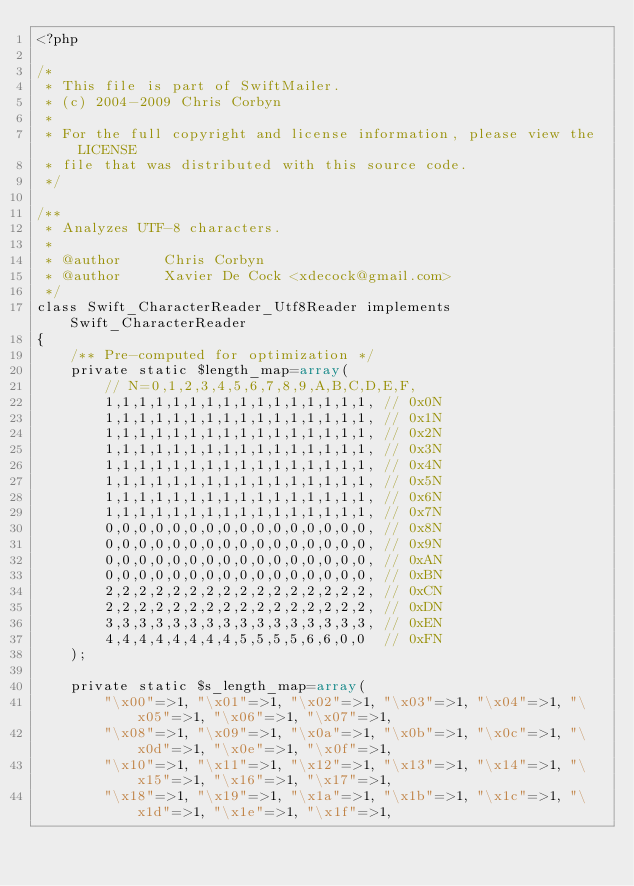Convert code to text. <code><loc_0><loc_0><loc_500><loc_500><_PHP_><?php

/*
 * This file is part of SwiftMailer.
 * (c) 2004-2009 Chris Corbyn
 *
 * For the full copyright and license information, please view the LICENSE
 * file that was distributed with this source code.
 */

/**
 * Analyzes UTF-8 characters.
 *
 * @author     Chris Corbyn
 * @author     Xavier De Cock <xdecock@gmail.com>
 */
class Swift_CharacterReader_Utf8Reader implements Swift_CharacterReader
{
    /** Pre-computed for optimization */
    private static $length_map=array(
        // N=0,1,2,3,4,5,6,7,8,9,A,B,C,D,E,F,
        1,1,1,1,1,1,1,1,1,1,1,1,1,1,1,1, // 0x0N
        1,1,1,1,1,1,1,1,1,1,1,1,1,1,1,1, // 0x1N
        1,1,1,1,1,1,1,1,1,1,1,1,1,1,1,1, // 0x2N
        1,1,1,1,1,1,1,1,1,1,1,1,1,1,1,1, // 0x3N
        1,1,1,1,1,1,1,1,1,1,1,1,1,1,1,1, // 0x4N
        1,1,1,1,1,1,1,1,1,1,1,1,1,1,1,1, // 0x5N
        1,1,1,1,1,1,1,1,1,1,1,1,1,1,1,1, // 0x6N
        1,1,1,1,1,1,1,1,1,1,1,1,1,1,1,1, // 0x7N
        0,0,0,0,0,0,0,0,0,0,0,0,0,0,0,0, // 0x8N
        0,0,0,0,0,0,0,0,0,0,0,0,0,0,0,0, // 0x9N
        0,0,0,0,0,0,0,0,0,0,0,0,0,0,0,0, // 0xAN
        0,0,0,0,0,0,0,0,0,0,0,0,0,0,0,0, // 0xBN
        2,2,2,2,2,2,2,2,2,2,2,2,2,2,2,2, // 0xCN
        2,2,2,2,2,2,2,2,2,2,2,2,2,2,2,2, // 0xDN
        3,3,3,3,3,3,3,3,3,3,3,3,3,3,3,3, // 0xEN
        4,4,4,4,4,4,4,4,5,5,5,5,6,6,0,0  // 0xFN
    );

    private static $s_length_map=array(
        "\x00"=>1, "\x01"=>1, "\x02"=>1, "\x03"=>1, "\x04"=>1, "\x05"=>1, "\x06"=>1, "\x07"=>1,
        "\x08"=>1, "\x09"=>1, "\x0a"=>1, "\x0b"=>1, "\x0c"=>1, "\x0d"=>1, "\x0e"=>1, "\x0f"=>1,
        "\x10"=>1, "\x11"=>1, "\x12"=>1, "\x13"=>1, "\x14"=>1, "\x15"=>1, "\x16"=>1, "\x17"=>1,
        "\x18"=>1, "\x19"=>1, "\x1a"=>1, "\x1b"=>1, "\x1c"=>1, "\x1d"=>1, "\x1e"=>1, "\x1f"=>1,</code> 